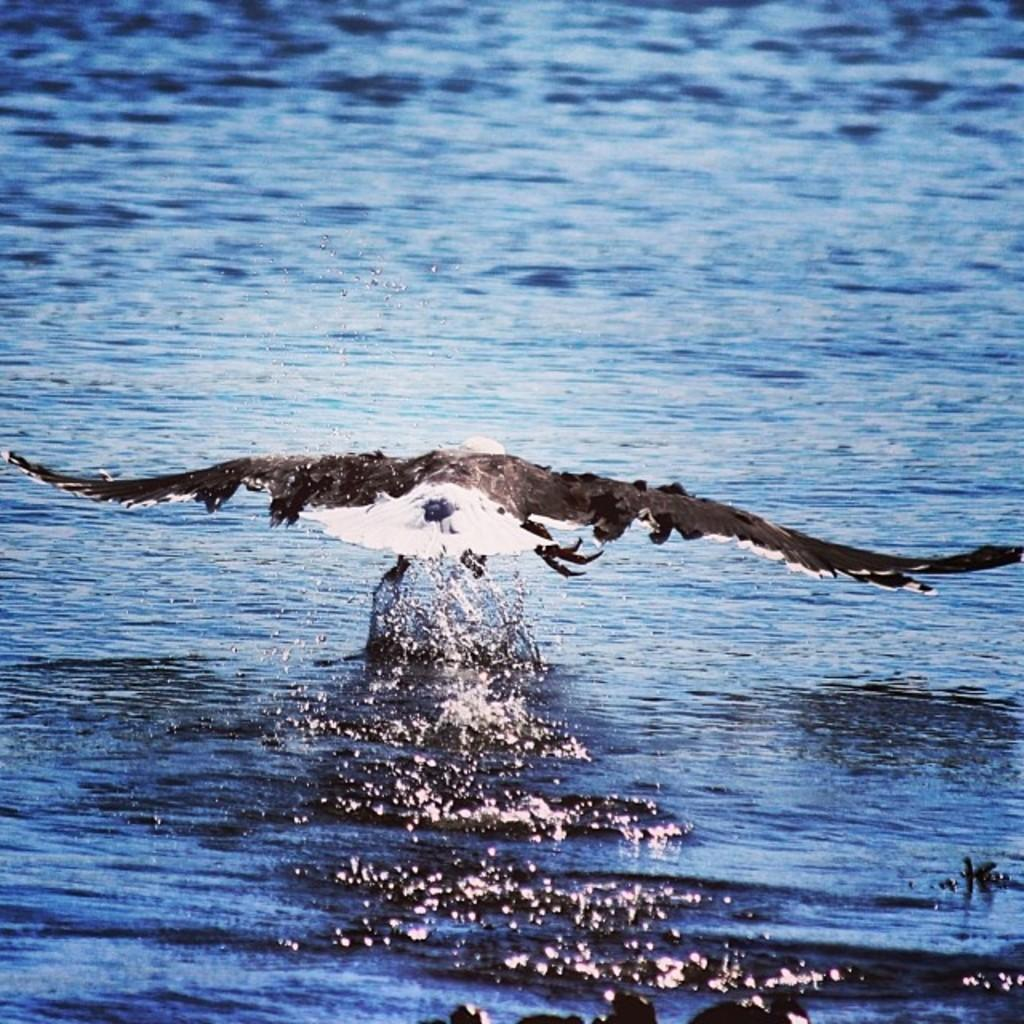What type of animal is in the image? There is a bird in the image. Can you describe the bird's coloring? The bird is white and black in color. What else can be seen in the image besides the bird? There is water visible in the image. What is the color of the water? The water is blue in color. What type of farm animals can be seen in the image? There are no farm animals present in the image; it features a bird and water. How does the bird show respect to the monkey in the image? There is no monkey present in the image, so the bird cannot show respect to it. 